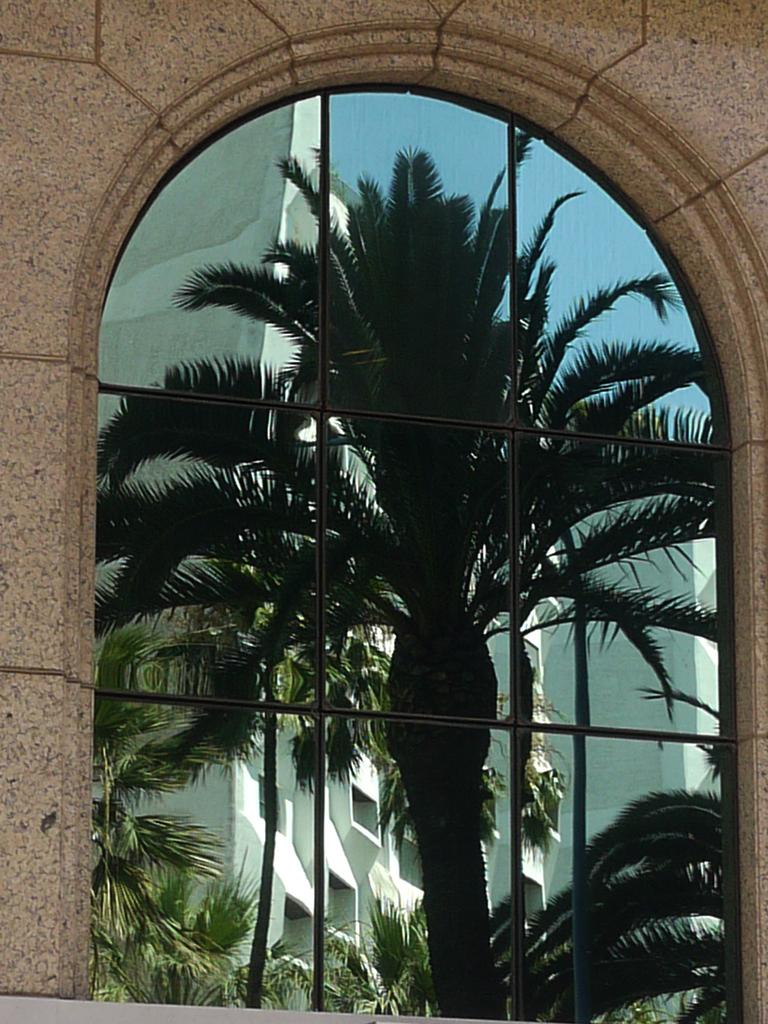What is the main object in the middle of the image? There is a glass in the middle of the image. What can be seen reflected in the glass? The glass reflects images of trees, buildings, and the sky. What surrounds the glass in the image? There is a wall around the glass. What type of garden can be seen in the reflection of the glass? There is no garden visible in the reflection of the glass; it shows images of trees, buildings, and the sky. 